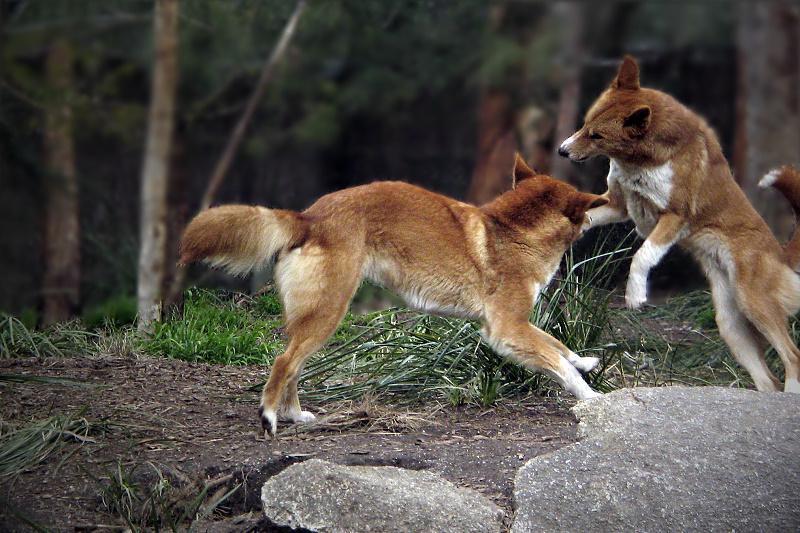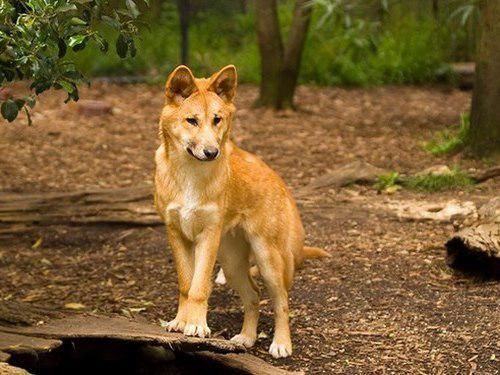The first image is the image on the left, the second image is the image on the right. For the images shown, is this caption "The left image contains at least two dingos." true? Answer yes or no. Yes. The first image is the image on the left, the second image is the image on the right. Evaluate the accuracy of this statement regarding the images: "There are two animals in total.". Is it true? Answer yes or no. No. 